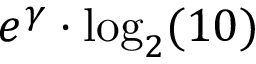<formula> <loc_0><loc_0><loc_500><loc_500>e ^ { \gamma } \cdot \log _ { 2 } ( 1 0 )</formula> 